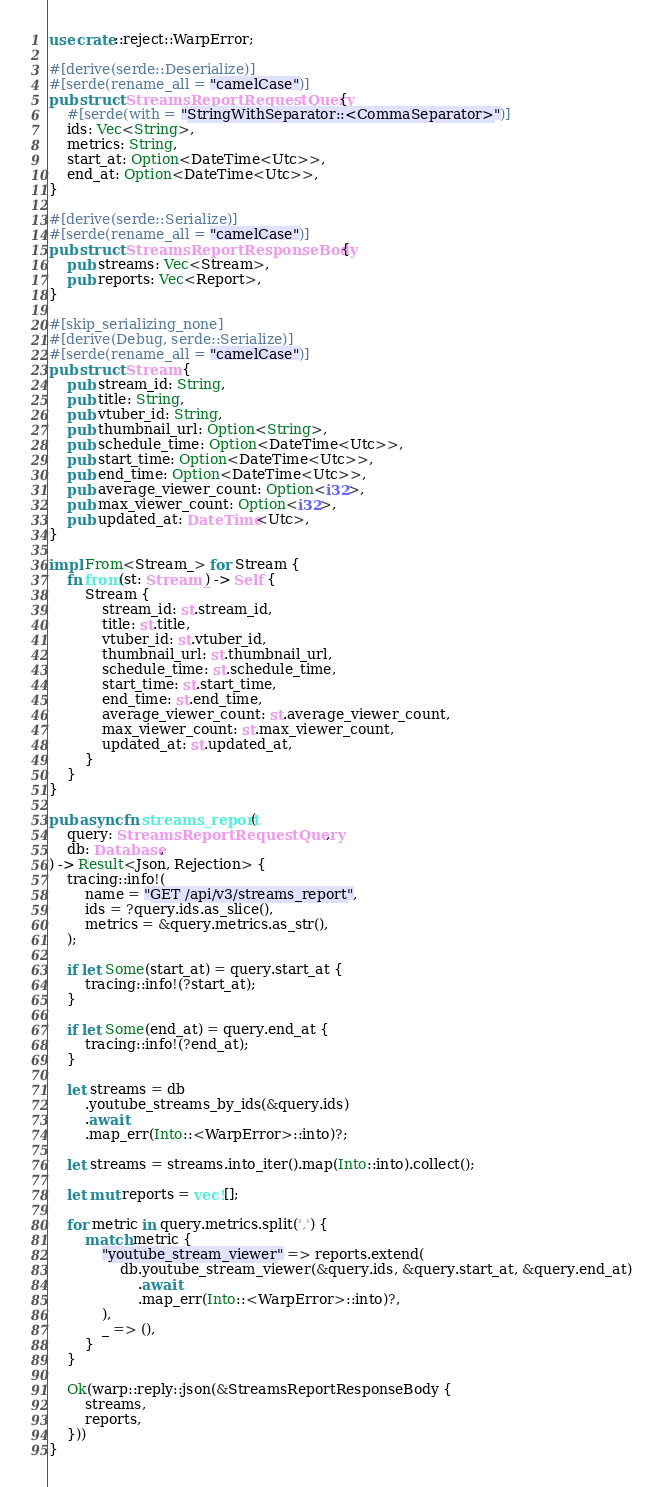<code> <loc_0><loc_0><loc_500><loc_500><_Rust_>use crate::reject::WarpError;

#[derive(serde::Deserialize)]
#[serde(rename_all = "camelCase")]
pub struct StreamsReportRequestQuery {
    #[serde(with = "StringWithSeparator::<CommaSeparator>")]
    ids: Vec<String>,
    metrics: String,
    start_at: Option<DateTime<Utc>>,
    end_at: Option<DateTime<Utc>>,
}

#[derive(serde::Serialize)]
#[serde(rename_all = "camelCase")]
pub struct StreamsReportResponseBody {
    pub streams: Vec<Stream>,
    pub reports: Vec<Report>,
}

#[skip_serializing_none]
#[derive(Debug, serde::Serialize)]
#[serde(rename_all = "camelCase")]
pub struct Stream {
    pub stream_id: String,
    pub title: String,
    pub vtuber_id: String,
    pub thumbnail_url: Option<String>,
    pub schedule_time: Option<DateTime<Utc>>,
    pub start_time: Option<DateTime<Utc>>,
    pub end_time: Option<DateTime<Utc>>,
    pub average_viewer_count: Option<i32>,
    pub max_viewer_count: Option<i32>,
    pub updated_at: DateTime<Utc>,
}

impl From<Stream_> for Stream {
    fn from(st: Stream_) -> Self {
        Stream {
            stream_id: st.stream_id,
            title: st.title,
            vtuber_id: st.vtuber_id,
            thumbnail_url: st.thumbnail_url,
            schedule_time: st.schedule_time,
            start_time: st.start_time,
            end_time: st.end_time,
            average_viewer_count: st.average_viewer_count,
            max_viewer_count: st.max_viewer_count,
            updated_at: st.updated_at,
        }
    }
}

pub async fn streams_report(
    query: StreamsReportRequestQuery,
    db: Database,
) -> Result<Json, Rejection> {
    tracing::info!(
        name = "GET /api/v3/streams_report",
        ids = ?query.ids.as_slice(),
        metrics = &query.metrics.as_str(),
    );

    if let Some(start_at) = query.start_at {
        tracing::info!(?start_at);
    }

    if let Some(end_at) = query.end_at {
        tracing::info!(?end_at);
    }

    let streams = db
        .youtube_streams_by_ids(&query.ids)
        .await
        .map_err(Into::<WarpError>::into)?;

    let streams = streams.into_iter().map(Into::into).collect();

    let mut reports = vec![];

    for metric in query.metrics.split(',') {
        match metric {
            "youtube_stream_viewer" => reports.extend(
                db.youtube_stream_viewer(&query.ids, &query.start_at, &query.end_at)
                    .await
                    .map_err(Into::<WarpError>::into)?,
            ),
            _ => (),
        }
    }

    Ok(warp::reply::json(&StreamsReportResponseBody {
        streams,
        reports,
    }))
}
</code> 